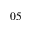Convert formula to latex. <formula><loc_0><loc_0><loc_500><loc_500>0 5</formula> 